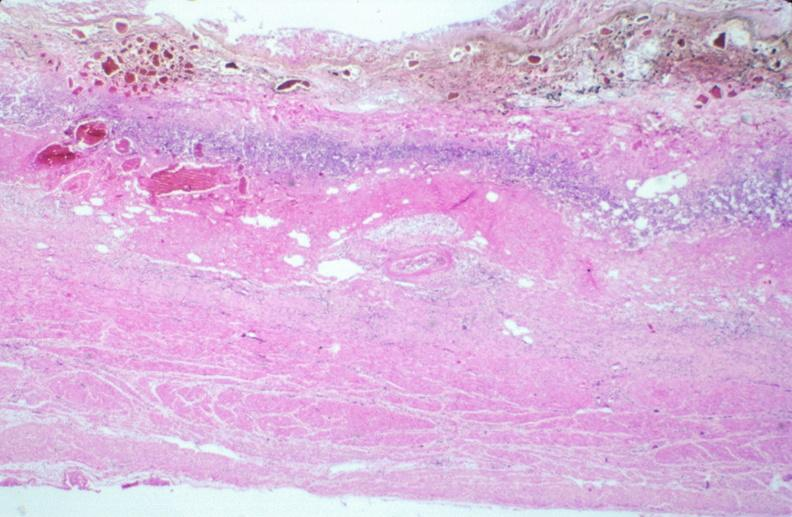what does this image show?
Answer the question using a single word or phrase. Stomach 